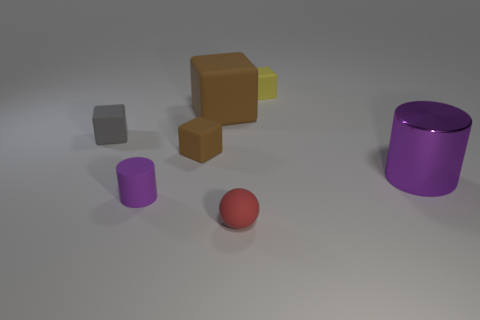Subtract all small cubes. How many cubes are left? 1 Subtract all yellow blocks. How many blocks are left? 3 Subtract 1 spheres. How many spheres are left? 0 Add 1 big purple objects. How many objects exist? 8 Subtract all yellow balls. How many brown blocks are left? 2 Subtract all cylinders. How many objects are left? 5 Subtract all big green objects. Subtract all red matte balls. How many objects are left? 6 Add 2 large purple shiny things. How many large purple shiny things are left? 3 Add 6 tiny blocks. How many tiny blocks exist? 9 Subtract 0 purple cubes. How many objects are left? 7 